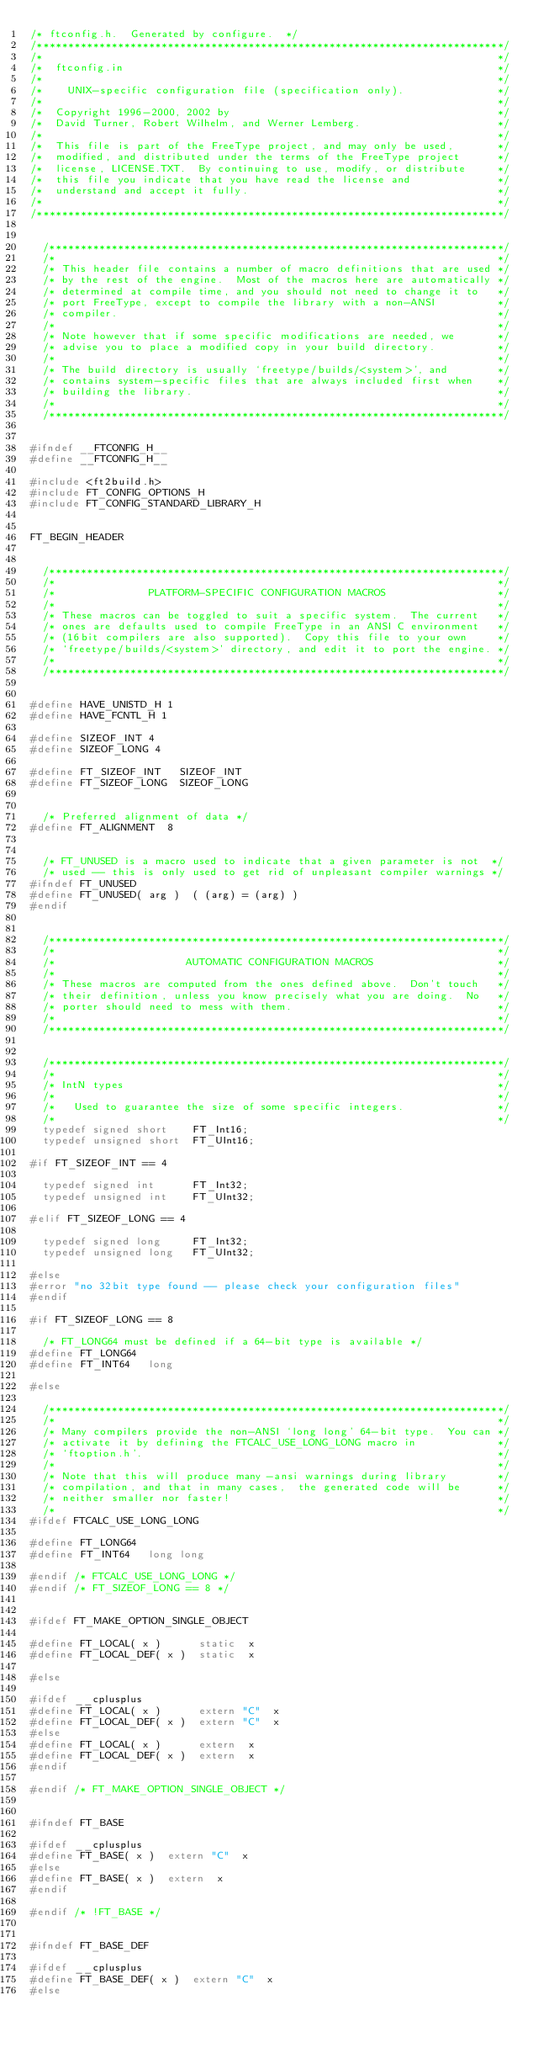<code> <loc_0><loc_0><loc_500><loc_500><_C_>/* ftconfig.h.  Generated by configure.  */
/***************************************************************************/
/*                                                                         */
/*  ftconfig.in                                                            */
/*                                                                         */
/*    UNIX-specific configuration file (specification only).               */
/*                                                                         */
/*  Copyright 1996-2000, 2002 by                                           */
/*  David Turner, Robert Wilhelm, and Werner Lemberg.                      */
/*                                                                         */
/*  This file is part of the FreeType project, and may only be used,       */
/*  modified, and distributed under the terms of the FreeType project      */
/*  license, LICENSE.TXT.  By continuing to use, modify, or distribute     */
/*  this file you indicate that you have read the license and              */
/*  understand and accept it fully.                                        */
/*                                                                         */
/***************************************************************************/


  /*************************************************************************/
  /*                                                                       */
  /* This header file contains a number of macro definitions that are used */
  /* by the rest of the engine.  Most of the macros here are automatically */
  /* determined at compile time, and you should not need to change it to   */
  /* port FreeType, except to compile the library with a non-ANSI          */
  /* compiler.                                                             */
  /*                                                                       */
  /* Note however that if some specific modifications are needed, we       */
  /* advise you to place a modified copy in your build directory.          */
  /*                                                                       */
  /* The build directory is usually `freetype/builds/<system>', and        */
  /* contains system-specific files that are always included first when    */
  /* building the library.                                                 */
  /*                                                                       */
  /*************************************************************************/


#ifndef __FTCONFIG_H__
#define __FTCONFIG_H__

#include <ft2build.h>
#include FT_CONFIG_OPTIONS_H
#include FT_CONFIG_STANDARD_LIBRARY_H


FT_BEGIN_HEADER


  /*************************************************************************/
  /*                                                                       */
  /*               PLATFORM-SPECIFIC CONFIGURATION MACROS                  */
  /*                                                                       */
  /* These macros can be toggled to suit a specific system.  The current   */
  /* ones are defaults used to compile FreeType in an ANSI C environment   */
  /* (16bit compilers are also supported).  Copy this file to your own     */
  /* `freetype/builds/<system>' directory, and edit it to port the engine. */
  /*                                                                       */
  /*************************************************************************/


#define HAVE_UNISTD_H 1
#define HAVE_FCNTL_H 1

#define SIZEOF_INT 4
#define SIZEOF_LONG 4

#define FT_SIZEOF_INT   SIZEOF_INT
#define FT_SIZEOF_LONG  SIZEOF_LONG


  /* Preferred alignment of data */
#define FT_ALIGNMENT  8


  /* FT_UNUSED is a macro used to indicate that a given parameter is not  */
  /* used -- this is only used to get rid of unpleasant compiler warnings */
#ifndef FT_UNUSED
#define FT_UNUSED( arg )  ( (arg) = (arg) )
#endif


  /*************************************************************************/
  /*                                                                       */
  /*                     AUTOMATIC CONFIGURATION MACROS                    */
  /*                                                                       */
  /* These macros are computed from the ones defined above.  Don't touch   */
  /* their definition, unless you know precisely what you are doing.  No   */
  /* porter should need to mess with them.                                 */
  /*                                                                       */
  /*************************************************************************/


  /*************************************************************************/
  /*                                                                       */
  /* IntN types                                                            */
  /*                                                                       */
  /*   Used to guarantee the size of some specific integers.               */
  /*                                                                       */
  typedef signed short    FT_Int16;
  typedef unsigned short  FT_UInt16;

#if FT_SIZEOF_INT == 4

  typedef signed int      FT_Int32;
  typedef unsigned int    FT_UInt32;

#elif FT_SIZEOF_LONG == 4

  typedef signed long     FT_Int32;
  typedef unsigned long   FT_UInt32;

#else
#error "no 32bit type found -- please check your configuration files"
#endif

#if FT_SIZEOF_LONG == 8

  /* FT_LONG64 must be defined if a 64-bit type is available */
#define FT_LONG64
#define FT_INT64   long

#else

  /*************************************************************************/
  /*                                                                       */
  /* Many compilers provide the non-ANSI `long long' 64-bit type.  You can */
  /* activate it by defining the FTCALC_USE_LONG_LONG macro in             */
  /* `ftoption.h'.                                                         */
  /*                                                                       */
  /* Note that this will produce many -ansi warnings during library        */
  /* compilation, and that in many cases,  the generated code will be      */
  /* neither smaller nor faster!                                           */
  /*                                                                       */
#ifdef FTCALC_USE_LONG_LONG

#define FT_LONG64
#define FT_INT64   long long

#endif /* FTCALC_USE_LONG_LONG */
#endif /* FT_SIZEOF_LONG == 8 */


#ifdef FT_MAKE_OPTION_SINGLE_OBJECT

#define FT_LOCAL( x )      static  x
#define FT_LOCAL_DEF( x )  static  x

#else

#ifdef __cplusplus
#define FT_LOCAL( x )      extern "C"  x
#define FT_LOCAL_DEF( x )  extern "C"  x
#else
#define FT_LOCAL( x )      extern  x
#define FT_LOCAL_DEF( x )  extern  x
#endif

#endif /* FT_MAKE_OPTION_SINGLE_OBJECT */


#ifndef FT_BASE

#ifdef __cplusplus
#define FT_BASE( x )  extern "C"  x
#else
#define FT_BASE( x )  extern  x
#endif

#endif /* !FT_BASE */


#ifndef FT_BASE_DEF

#ifdef __cplusplus
#define FT_BASE_DEF( x )  extern "C"  x
#else</code> 